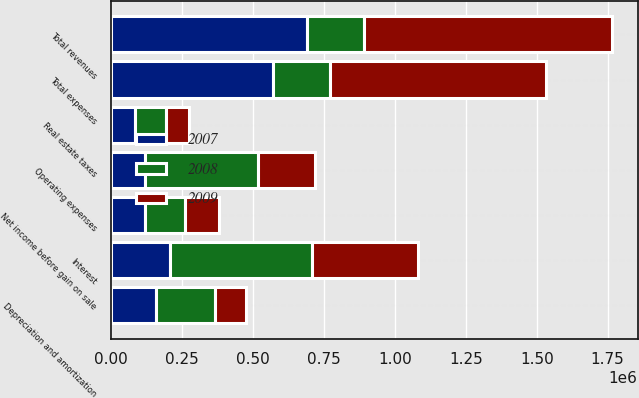<chart> <loc_0><loc_0><loc_500><loc_500><stacked_bar_chart><ecel><fcel>Total revenues<fcel>Operating expenses<fcel>Real estate taxes<fcel>Interest<fcel>Depreciation and amortization<fcel>Total expenses<fcel>Net income before gain on sale<nl><fcel>2007<fcel>689087<fcel>120215<fcel>84827<fcel>208295<fcel>156470<fcel>569807<fcel>119280<nl><fcel>2008<fcel>201125<fcel>395872<fcel>109002<fcel>499710<fcel>210425<fcel>201125<fcel>142210<nl><fcel>2009<fcel>876819<fcel>201125<fcel>79182<fcel>371632<fcel>108187<fcel>760126<fcel>116693<nl></chart> 